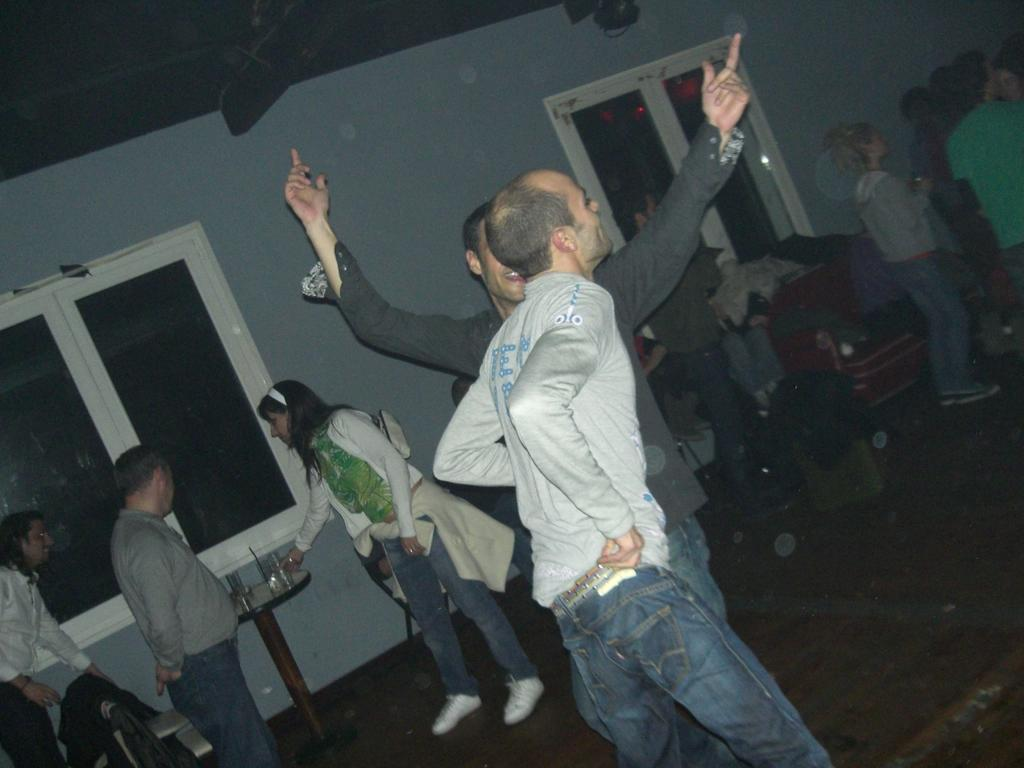What is the main subject of the image? There is a group of people in the image. What can be seen in the background of the image? There are chairs, glasses on a table, and Baggage visible in the background of the image. What type of note is being played by the group of people in the image? There is no indication of any musical instruments or notes being played in the image. 